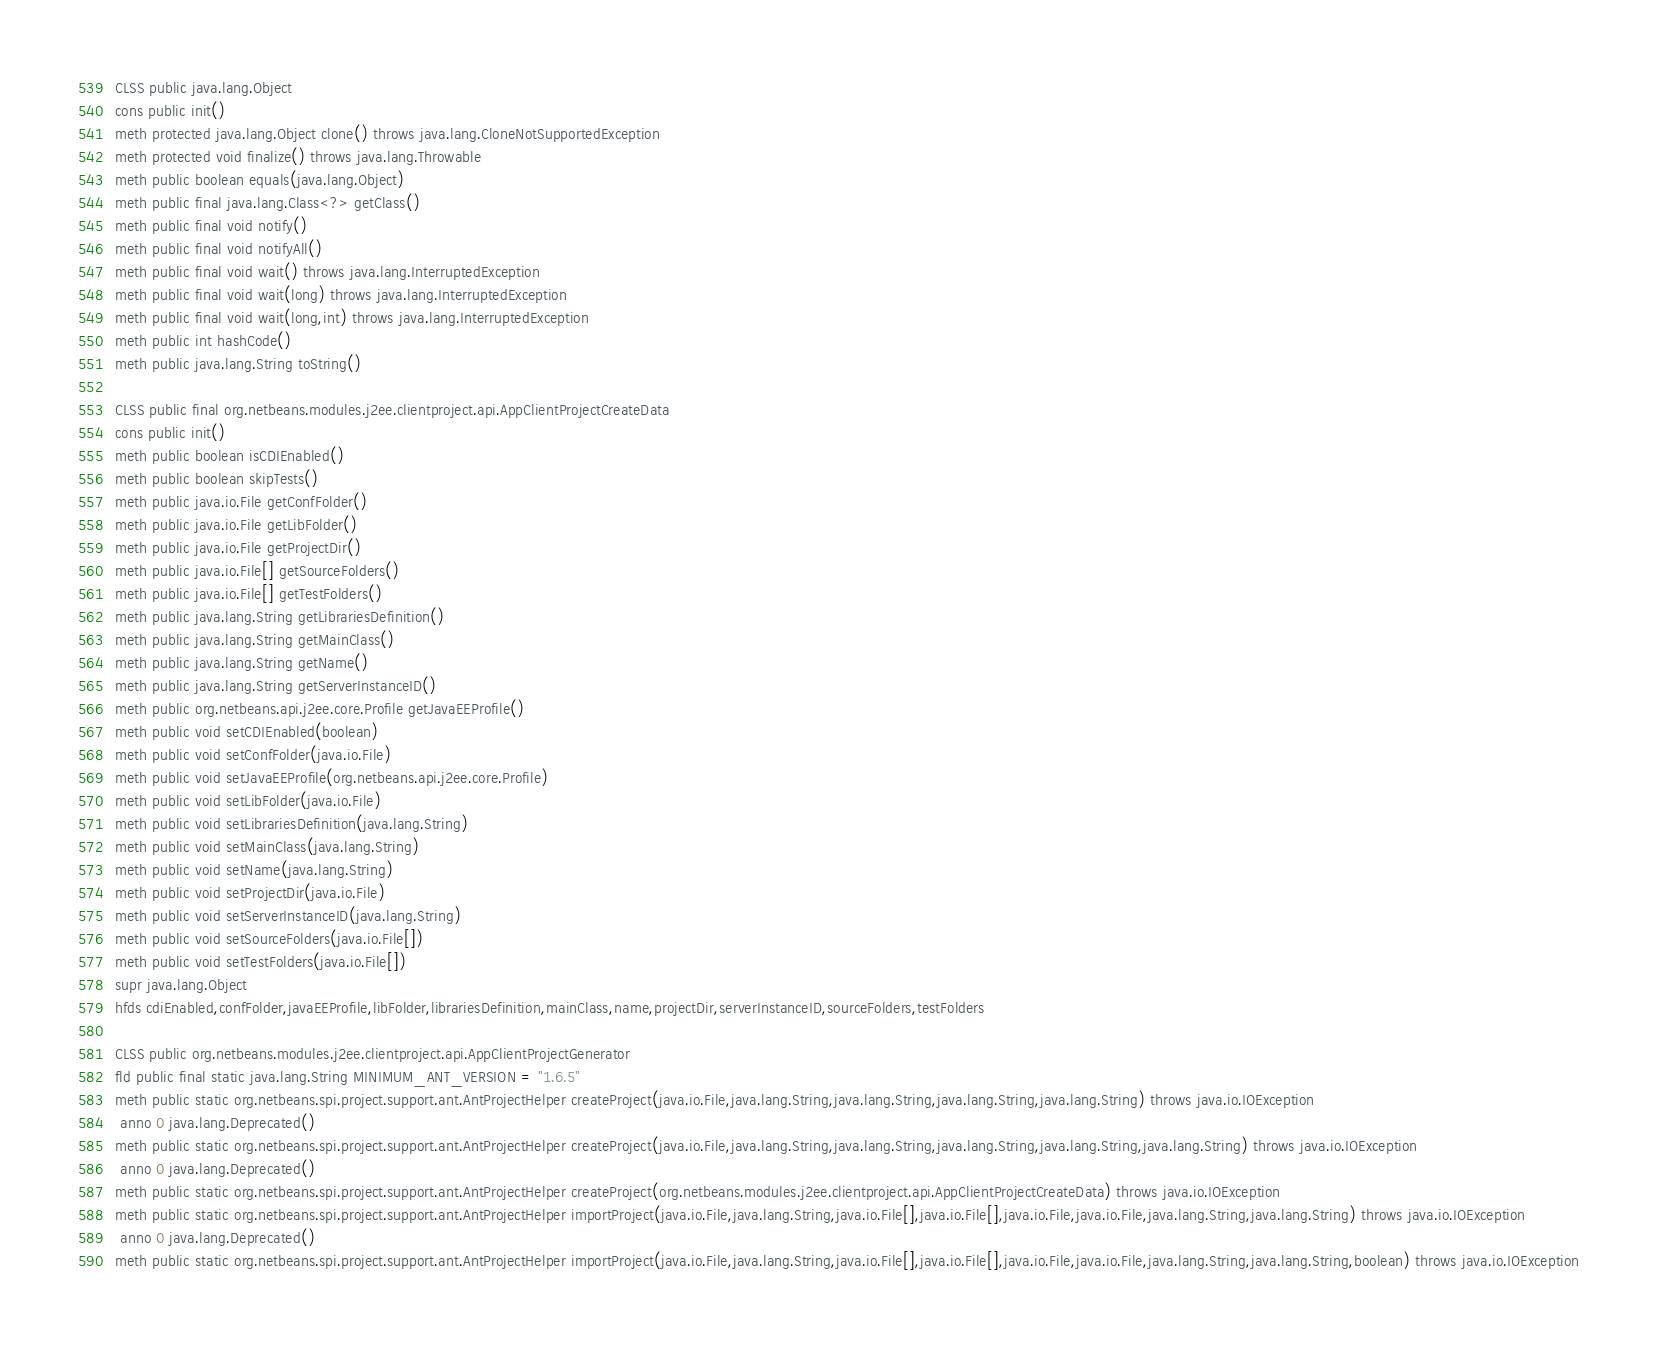<code> <loc_0><loc_0><loc_500><loc_500><_SML_>CLSS public java.lang.Object
cons public init()
meth protected java.lang.Object clone() throws java.lang.CloneNotSupportedException
meth protected void finalize() throws java.lang.Throwable
meth public boolean equals(java.lang.Object)
meth public final java.lang.Class<?> getClass()
meth public final void notify()
meth public final void notifyAll()
meth public final void wait() throws java.lang.InterruptedException
meth public final void wait(long) throws java.lang.InterruptedException
meth public final void wait(long,int) throws java.lang.InterruptedException
meth public int hashCode()
meth public java.lang.String toString()

CLSS public final org.netbeans.modules.j2ee.clientproject.api.AppClientProjectCreateData
cons public init()
meth public boolean isCDIEnabled()
meth public boolean skipTests()
meth public java.io.File getConfFolder()
meth public java.io.File getLibFolder()
meth public java.io.File getProjectDir()
meth public java.io.File[] getSourceFolders()
meth public java.io.File[] getTestFolders()
meth public java.lang.String getLibrariesDefinition()
meth public java.lang.String getMainClass()
meth public java.lang.String getName()
meth public java.lang.String getServerInstanceID()
meth public org.netbeans.api.j2ee.core.Profile getJavaEEProfile()
meth public void setCDIEnabled(boolean)
meth public void setConfFolder(java.io.File)
meth public void setJavaEEProfile(org.netbeans.api.j2ee.core.Profile)
meth public void setLibFolder(java.io.File)
meth public void setLibrariesDefinition(java.lang.String)
meth public void setMainClass(java.lang.String)
meth public void setName(java.lang.String)
meth public void setProjectDir(java.io.File)
meth public void setServerInstanceID(java.lang.String)
meth public void setSourceFolders(java.io.File[])
meth public void setTestFolders(java.io.File[])
supr java.lang.Object
hfds cdiEnabled,confFolder,javaEEProfile,libFolder,librariesDefinition,mainClass,name,projectDir,serverInstanceID,sourceFolders,testFolders

CLSS public org.netbeans.modules.j2ee.clientproject.api.AppClientProjectGenerator
fld public final static java.lang.String MINIMUM_ANT_VERSION = "1.6.5"
meth public static org.netbeans.spi.project.support.ant.AntProjectHelper createProject(java.io.File,java.lang.String,java.lang.String,java.lang.String,java.lang.String) throws java.io.IOException
 anno 0 java.lang.Deprecated()
meth public static org.netbeans.spi.project.support.ant.AntProjectHelper createProject(java.io.File,java.lang.String,java.lang.String,java.lang.String,java.lang.String,java.lang.String) throws java.io.IOException
 anno 0 java.lang.Deprecated()
meth public static org.netbeans.spi.project.support.ant.AntProjectHelper createProject(org.netbeans.modules.j2ee.clientproject.api.AppClientProjectCreateData) throws java.io.IOException
meth public static org.netbeans.spi.project.support.ant.AntProjectHelper importProject(java.io.File,java.lang.String,java.io.File[],java.io.File[],java.io.File,java.io.File,java.lang.String,java.lang.String) throws java.io.IOException
 anno 0 java.lang.Deprecated()
meth public static org.netbeans.spi.project.support.ant.AntProjectHelper importProject(java.io.File,java.lang.String,java.io.File[],java.io.File[],java.io.File,java.io.File,java.lang.String,java.lang.String,boolean) throws java.io.IOException</code> 